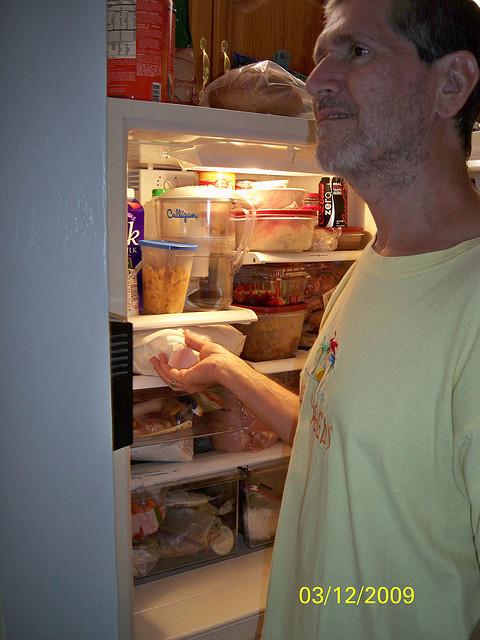What fruit is on the top shelf?
Keep it brief. Strawberry. Is the fridge crowded?
Concise answer only. Yes. IS the food inside cold?
Answer briefly. Yes. What is most of the food stored in?
Write a very short answer. Fridge. What is the man reaching into?
Answer briefly. Refrigerator. Does the refrigerator full or empty?
Concise answer only. Full. Do they have chocolate eclairs?
Give a very brief answer. No. 